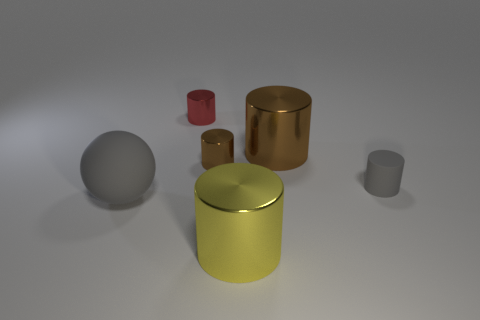Subtract all tiny brown metal cylinders. How many cylinders are left? 4 Subtract all red cylinders. How many cylinders are left? 4 Subtract all cyan cylinders. Subtract all brown spheres. How many cylinders are left? 5 Add 4 cyan rubber objects. How many objects exist? 10 Subtract all cylinders. How many objects are left? 1 Add 6 small brown cylinders. How many small brown cylinders exist? 7 Subtract 0 red cubes. How many objects are left? 6 Subtract all yellow shiny objects. Subtract all large gray rubber blocks. How many objects are left? 5 Add 4 large yellow metallic objects. How many large yellow metallic objects are left? 5 